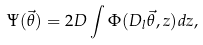Convert formula to latex. <formula><loc_0><loc_0><loc_500><loc_500>\Psi ( \vec { \theta } ) = 2 D \int \Phi ( D _ { l } \vec { \theta } , z ) d z ,</formula> 